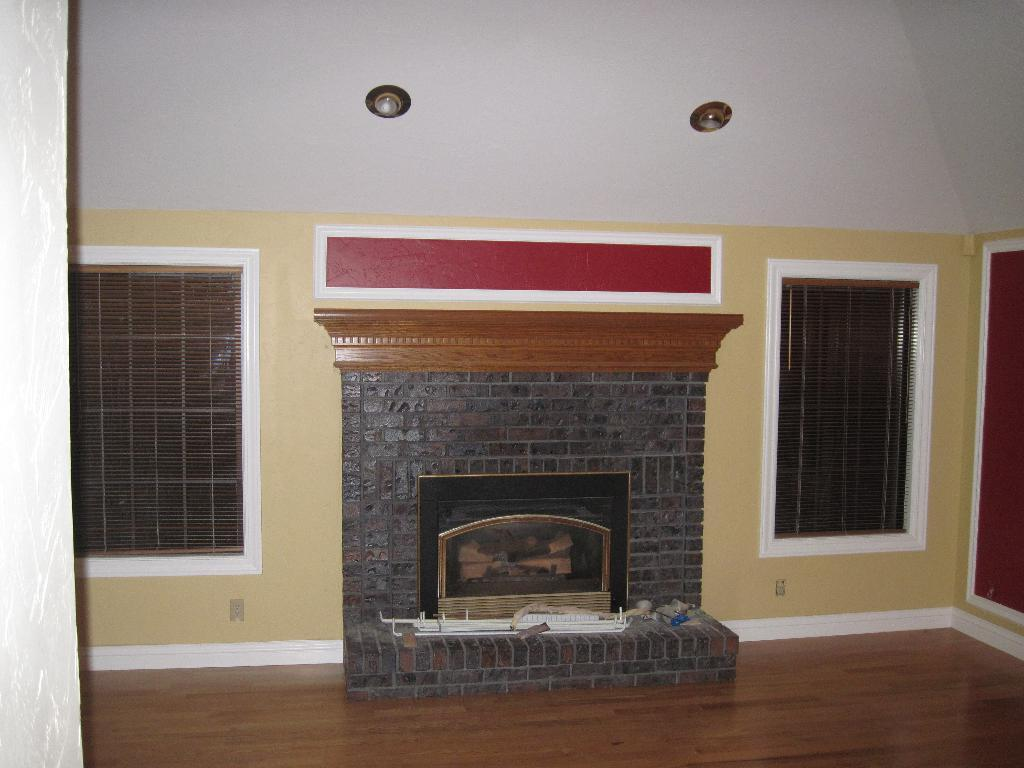What type of space is shown in the image? The image is an inside view of a room. What is a prominent feature in the room? There is a fireplace in the room. What surrounds the room? There are walls in the room. What provides illumination in the room? There are lights in the room. What type of window treatment is present in the room? There are window shutters in the room. What type of button can be seen on the fireplace in the image? There is no button present on the fireplace in the image. How many boots are visible in the room? There are no boots visible in the room; the image only shows a fireplace, walls, lights, and window shutters. 